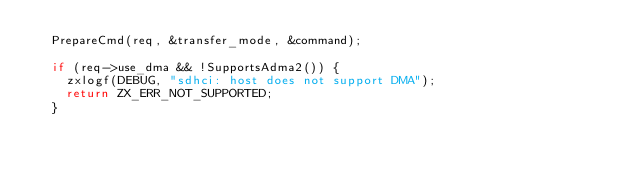<code> <loc_0><loc_0><loc_500><loc_500><_C++_>  PrepareCmd(req, &transfer_mode, &command);

  if (req->use_dma && !SupportsAdma2()) {
    zxlogf(DEBUG, "sdhci: host does not support DMA");
    return ZX_ERR_NOT_SUPPORTED;
  }
</code> 